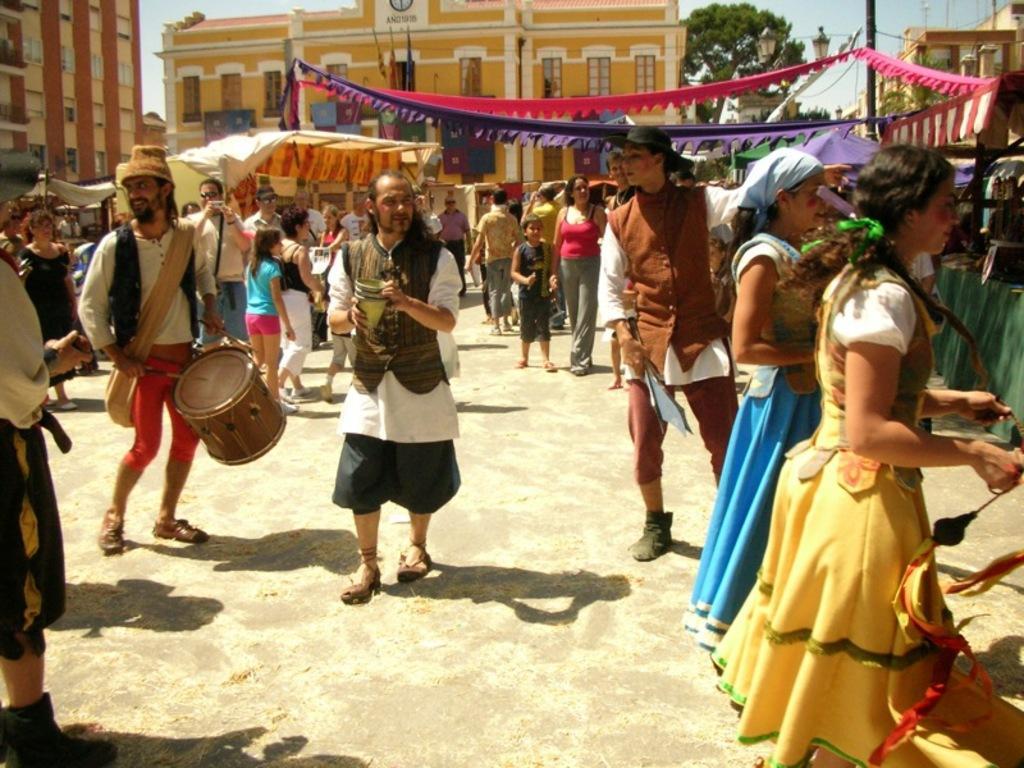Could you give a brief overview of what you see in this image? Few persons are standing and few persons are walking,this person holding drum,this person holding camera and this person holding object. On the background we can see buildings,tree,skylight,pole,tents. 